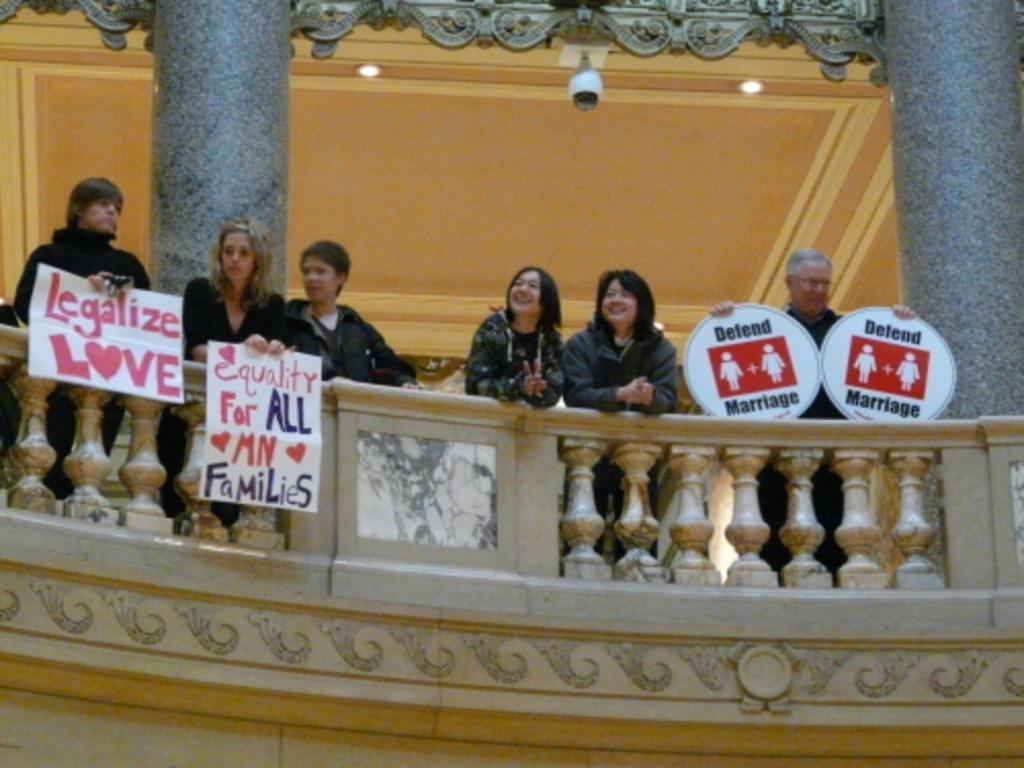How many people are present in the image? There are six people standing in the image. What are the people wearing? The people are wearing clothes. What are some of the people holding in the image? Some of the people are holding posters. What architectural features can be seen in the image? There is a fence, pillars, and a roof in the image. What type of lighting is present in the image? There are lights in the image. What type of banana is being used as apparel by the people in the image? There is no banana being used as apparel in the image; the people are wearing clothes. Can you tell me how many dogs are present in the image? There are no dogs present in the image. 